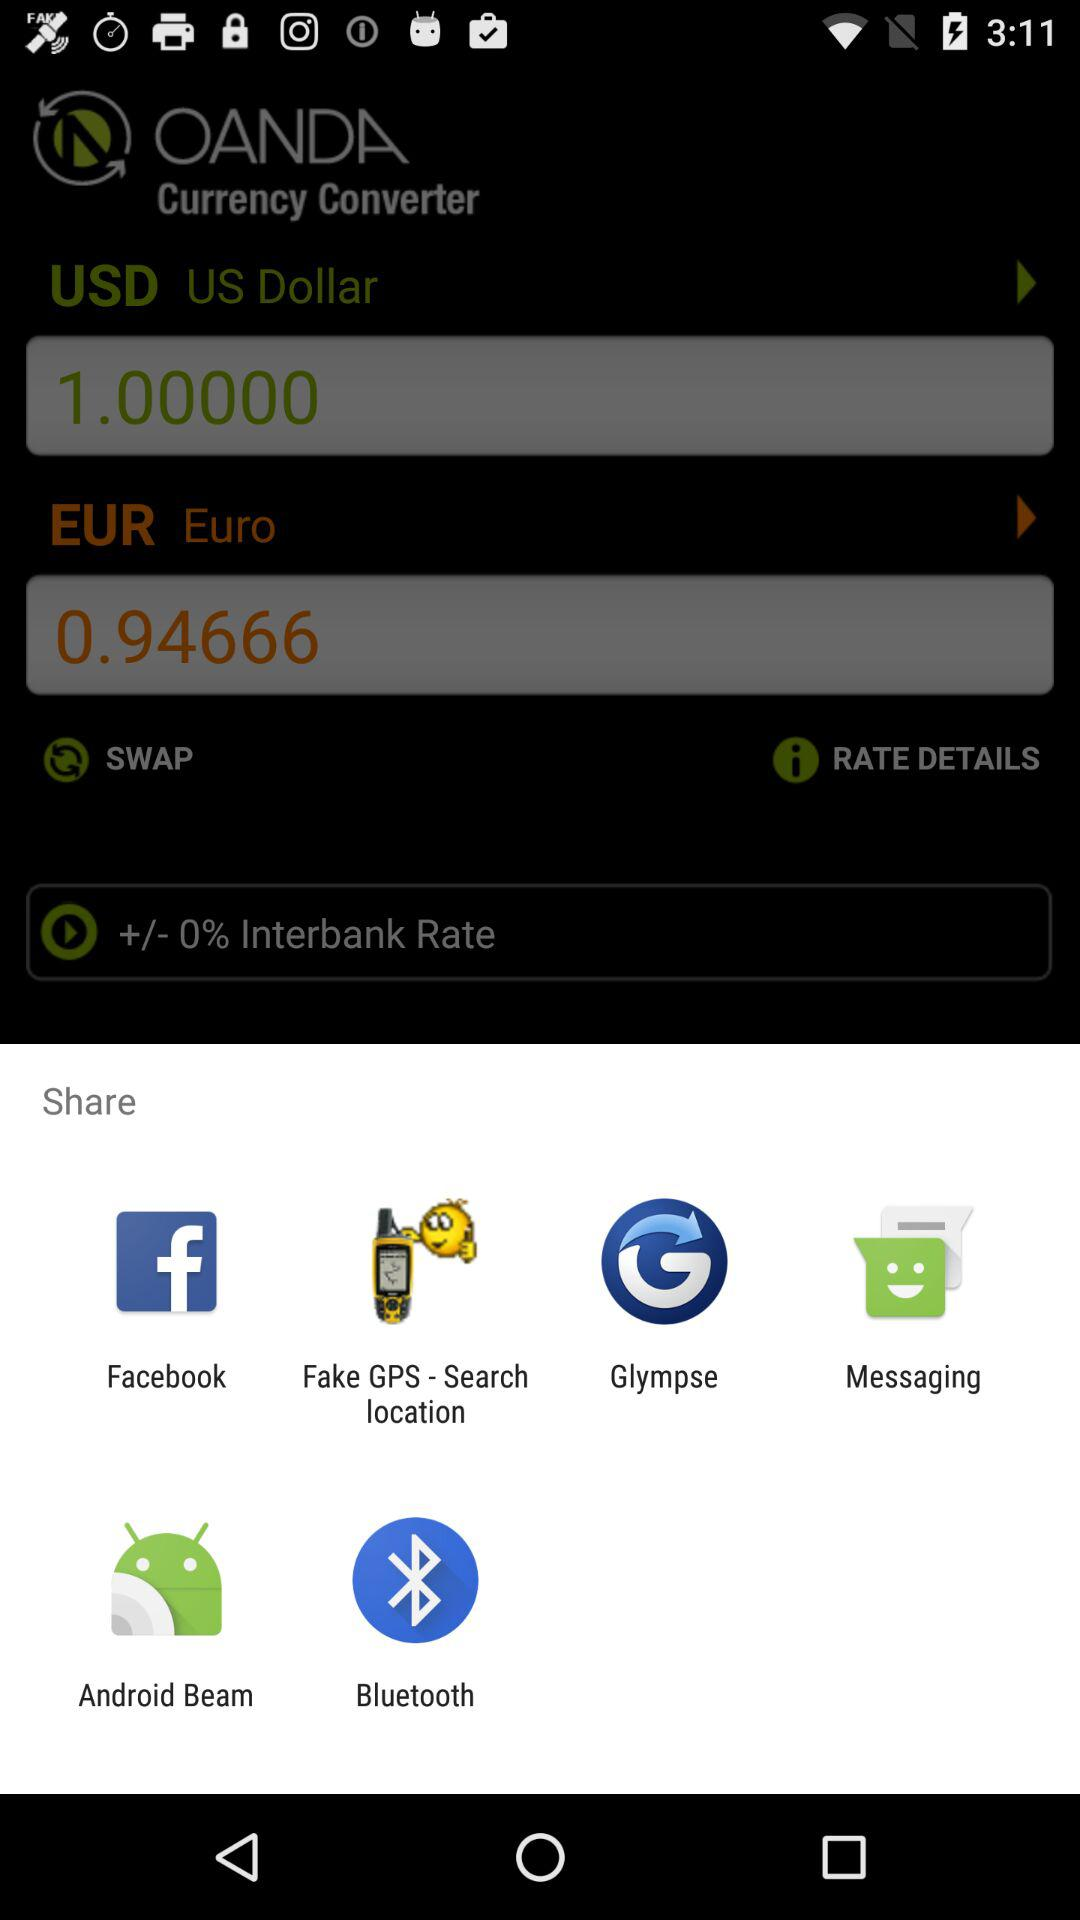Through which application can we share the "Currency Converter"? You can share through "Facebook", "Fake GPS - Search location", "Glympse", "Messaging", "Android Beam" and "Bluetooth". 